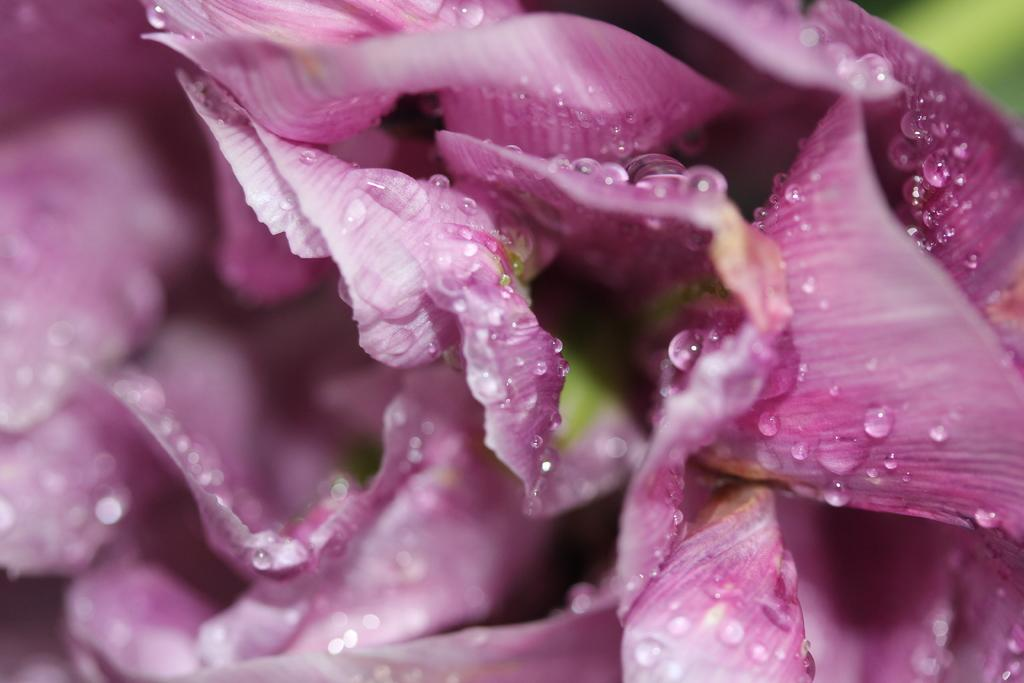What type of flowers are represented in the image? The image contains petals of flowers. What color are the petals? The petals are in pink color. Are there any additional features on the petals? Yes, there are droplets on the petals. What type of cloth is being used to cover the tent in the image? There is no cloth or tent present in the image; it only features petals of flowers with droplets on them. 